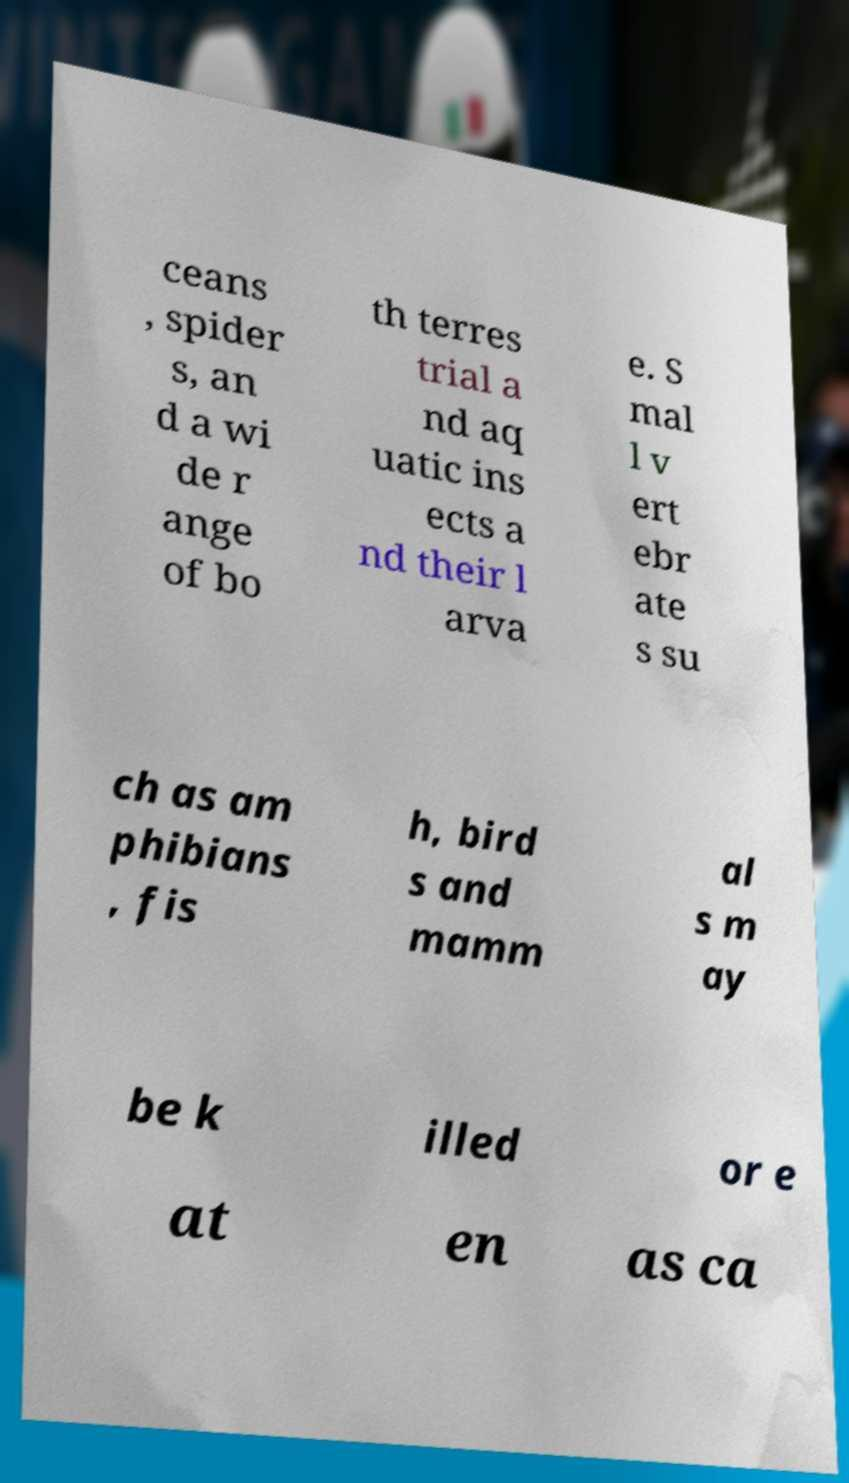Please read and relay the text visible in this image. What does it say? ceans , spider s, an d a wi de r ange of bo th terres trial a nd aq uatic ins ects a nd their l arva e. S mal l v ert ebr ate s su ch as am phibians , fis h, bird s and mamm al s m ay be k illed or e at en as ca 